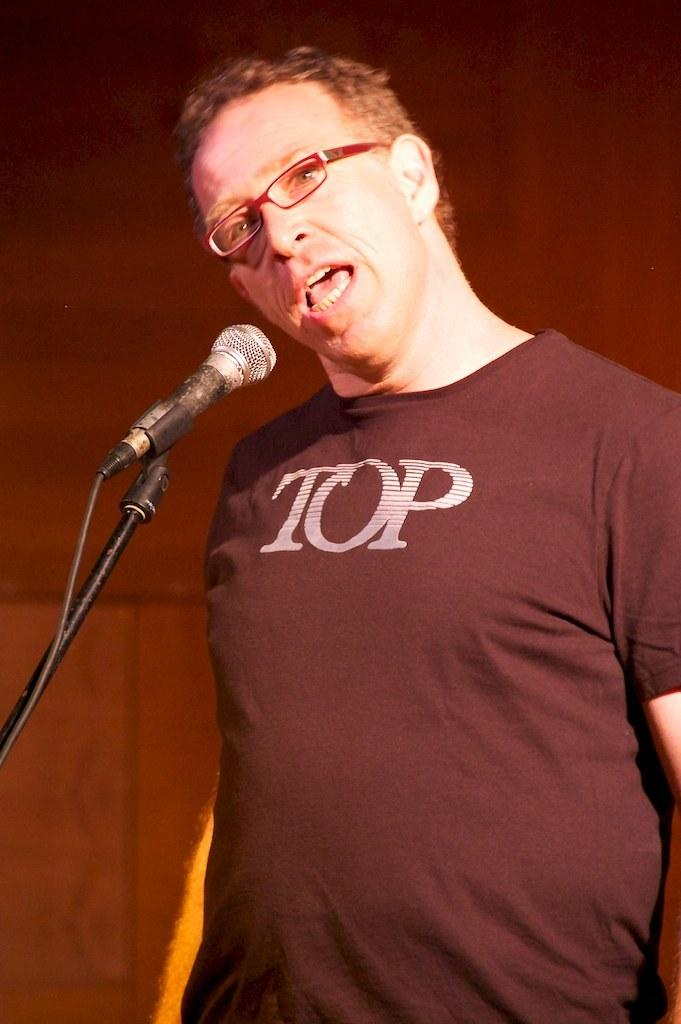Who is present in the image? There is a man in the image. What is the man wearing? The man is wearing clothes and spectacles. What is the man doing in the image? The man is talking. What object is in front of the man? There is a microphone and a cable wire in front of the man. What can be observed about the background of the image? The background of the image is blurred. What type of throne is the man sitting on in the image? There is no throne present in the image; the man is standing and talking. What business is the man discussing with the fork in the image? There is no fork present in the image, and the man is not discussing any business. 